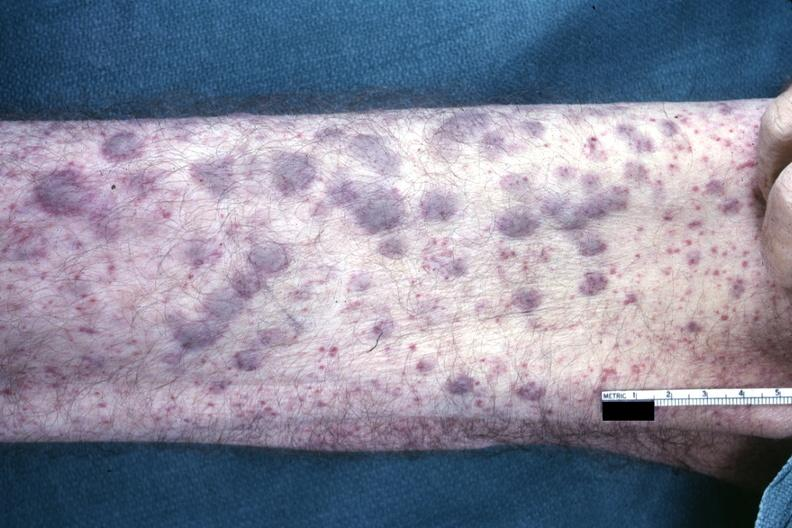s acute myelogenous leukemia present?
Answer the question using a single word or phrase. Yes 